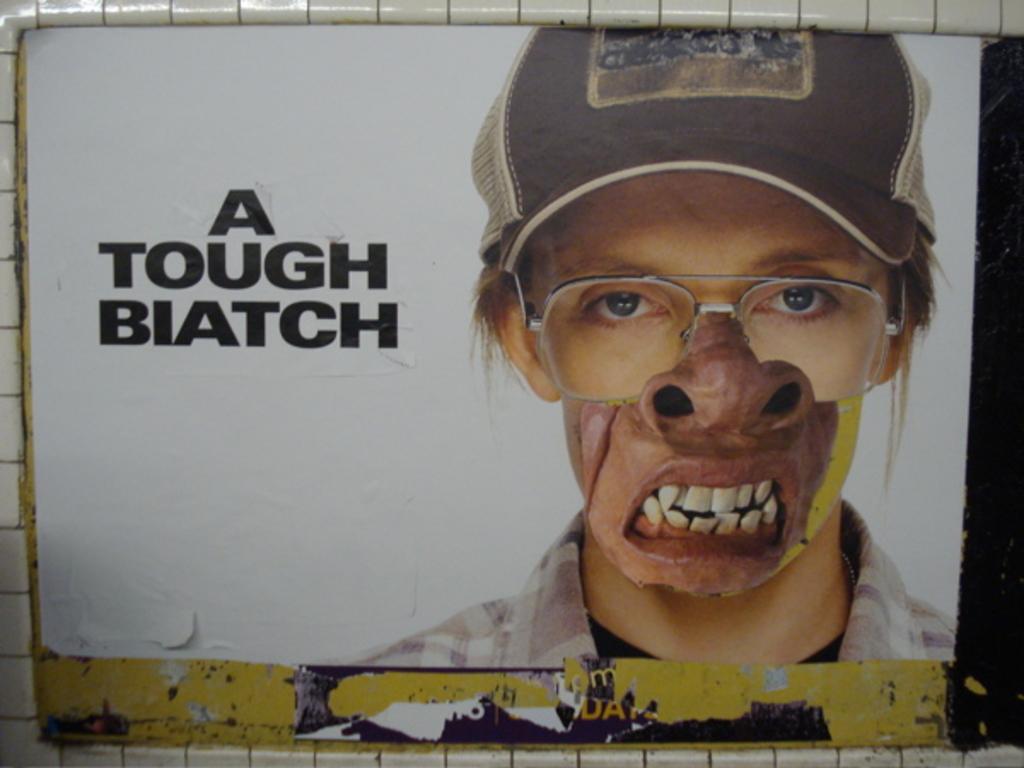In one or two sentences, can you explain what this image depicts? This is the poster where we can see a human image and some text. 